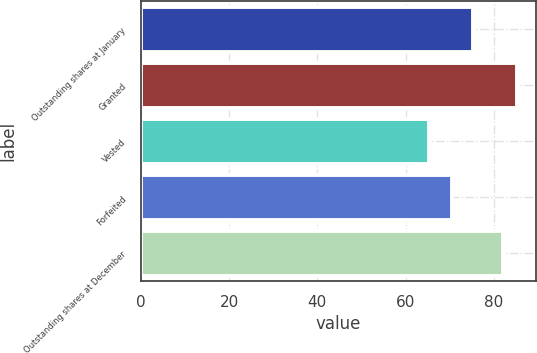<chart> <loc_0><loc_0><loc_500><loc_500><bar_chart><fcel>Outstanding shares at January<fcel>Granted<fcel>Vested<fcel>Forfeited<fcel>Outstanding shares at December<nl><fcel>75.33<fcel>85.26<fcel>65.36<fcel>70.53<fcel>82.02<nl></chart> 